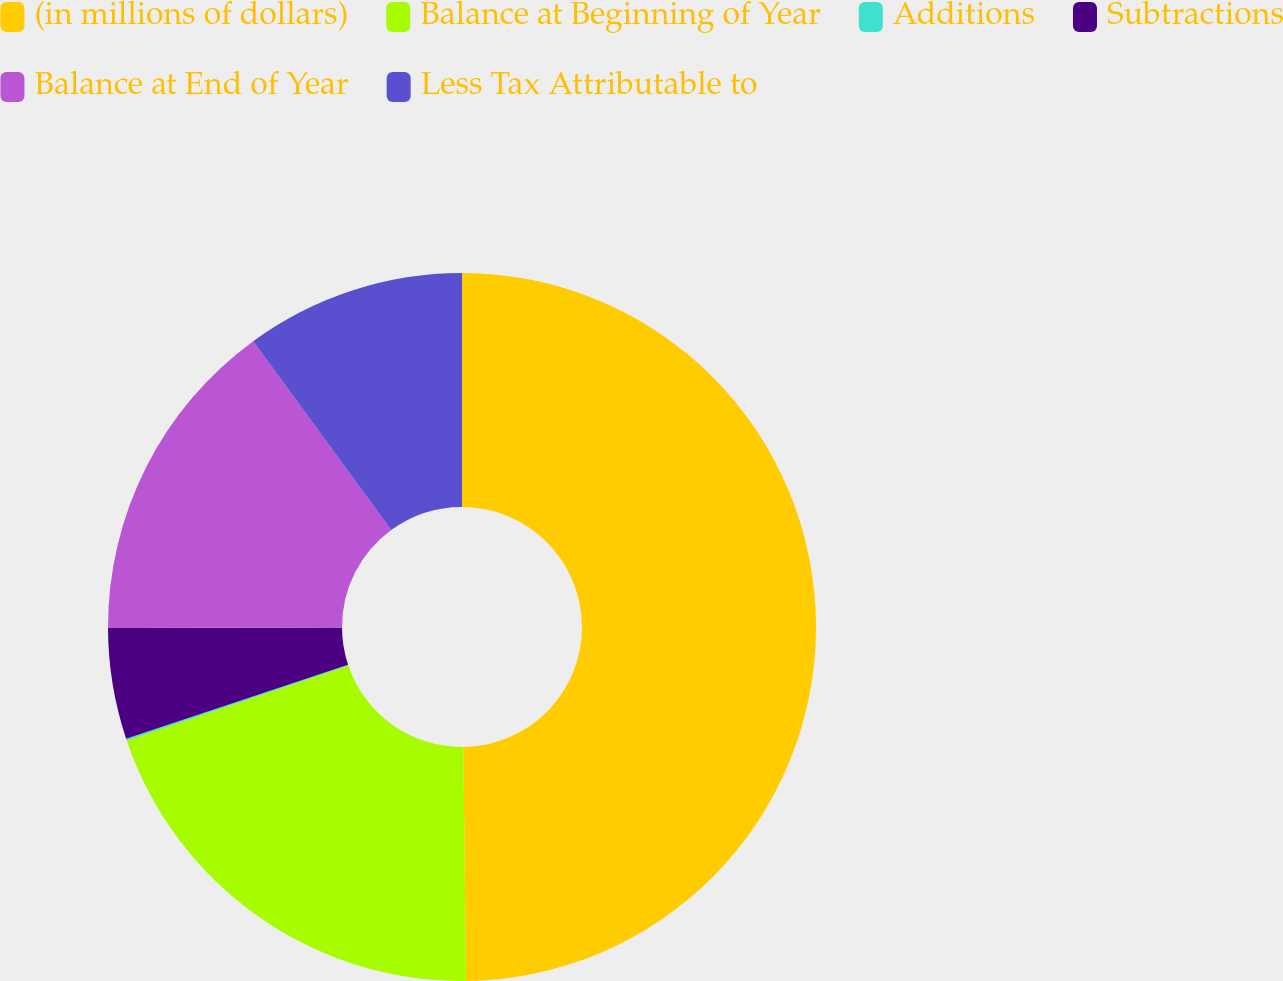<chart> <loc_0><loc_0><loc_500><loc_500><pie_chart><fcel>(in millions of dollars)<fcel>Balance at Beginning of Year<fcel>Additions<fcel>Subtractions<fcel>Balance at End of Year<fcel>Less Tax Attributable to<nl><fcel>49.82%<fcel>19.98%<fcel>0.09%<fcel>5.06%<fcel>15.01%<fcel>10.04%<nl></chart> 